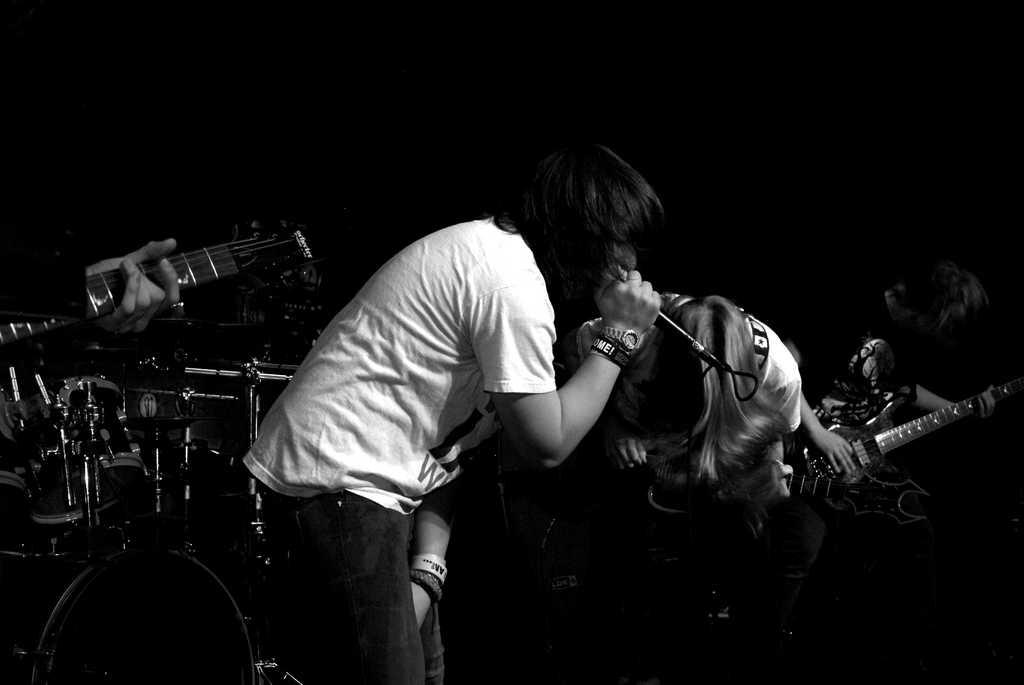What is the person in the image wearing? The person in the image is wearing a white shirt. What is the person doing in the image? The person is singing. What object is the person holding while singing? The person is holding a microphone. What can be seen in the background of the image? There are people playing musical instruments in the background. Can you identify any specific musical instruments in the background? Yes, a guitar and drums are present among the musical instruments. What type of milk is being poured into the frame in the image? There is no milk or frame present in the image; it features a person singing with a microphone and people playing musical instruments in the background. 